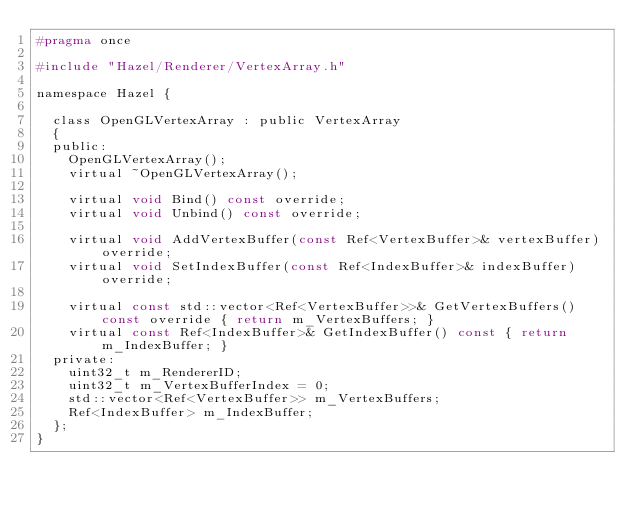<code> <loc_0><loc_0><loc_500><loc_500><_C_>#pragma once

#include "Hazel/Renderer/VertexArray.h"

namespace Hazel {

	class OpenGLVertexArray : public VertexArray
	{
	public:
		OpenGLVertexArray();
		virtual ~OpenGLVertexArray();

		virtual void Bind() const override;
		virtual void Unbind() const override;

		virtual void AddVertexBuffer(const Ref<VertexBuffer>& vertexBuffer) override;
		virtual void SetIndexBuffer(const Ref<IndexBuffer>& indexBuffer) override;

		virtual const std::vector<Ref<VertexBuffer>>& GetVertexBuffers() const override { return m_VertexBuffers; }
		virtual const Ref<IndexBuffer>& GetIndexBuffer() const { return m_IndexBuffer; }
	private:
		uint32_t m_RendererID;
		uint32_t m_VertexBufferIndex = 0;
		std::vector<Ref<VertexBuffer>> m_VertexBuffers;
		Ref<IndexBuffer> m_IndexBuffer;
	};
}
</code> 